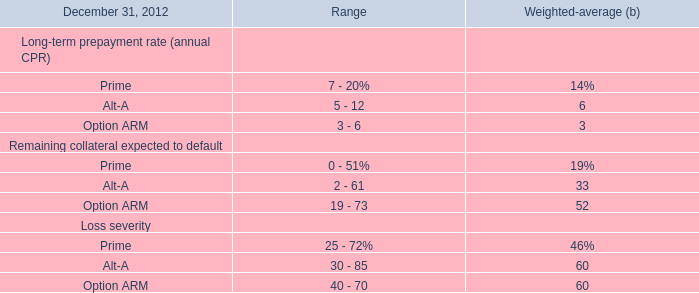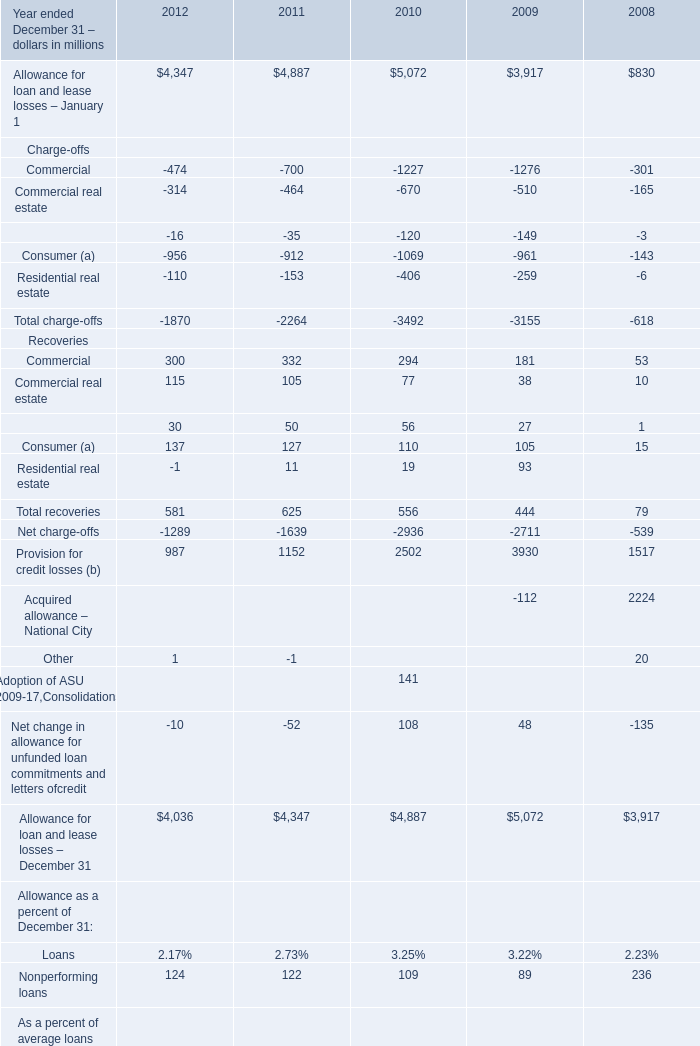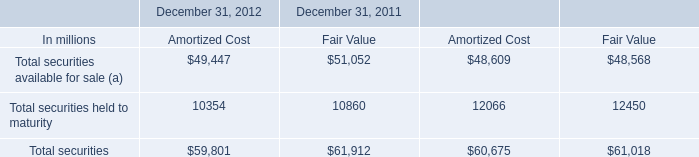how many total assets were there at year ended dec 31 , 2011 , in millions? 
Computations: (60.6 - (100 / 22))
Answer: 56.05455. 